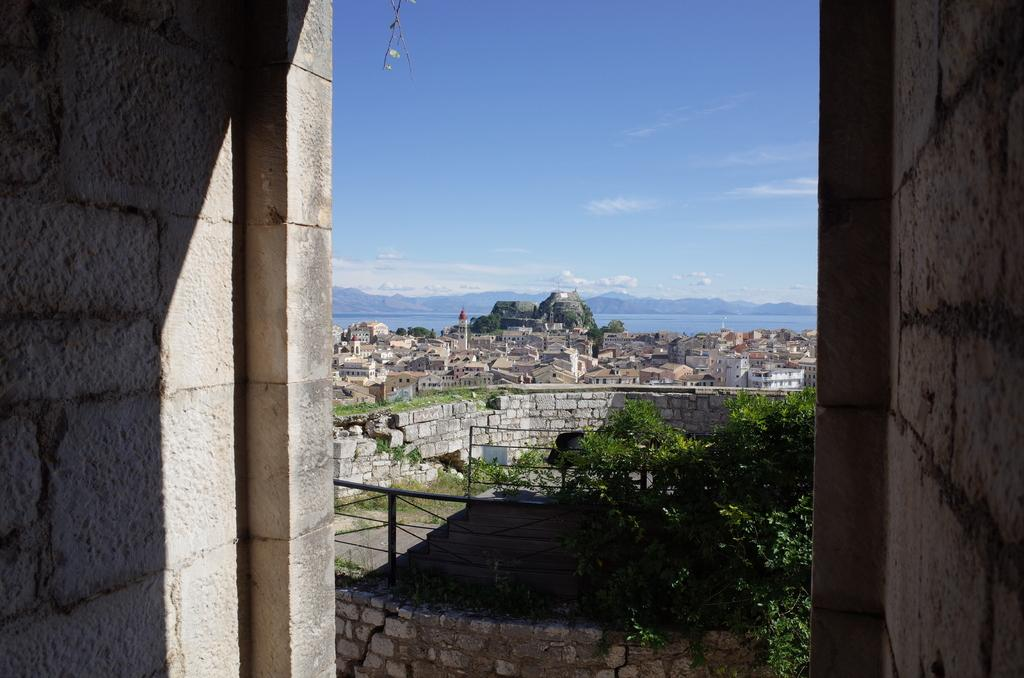What type of structures can be seen in the image? There are buildings in the image. What type of natural elements are present in the image? There are trees in the image. What type of barrier can be seen in the image? There is fencing in the image. How many fish can be seen swimming in the image? There are no fish present in the image. What type of furniture can be seen in the image? There is no furniture present in the image. 